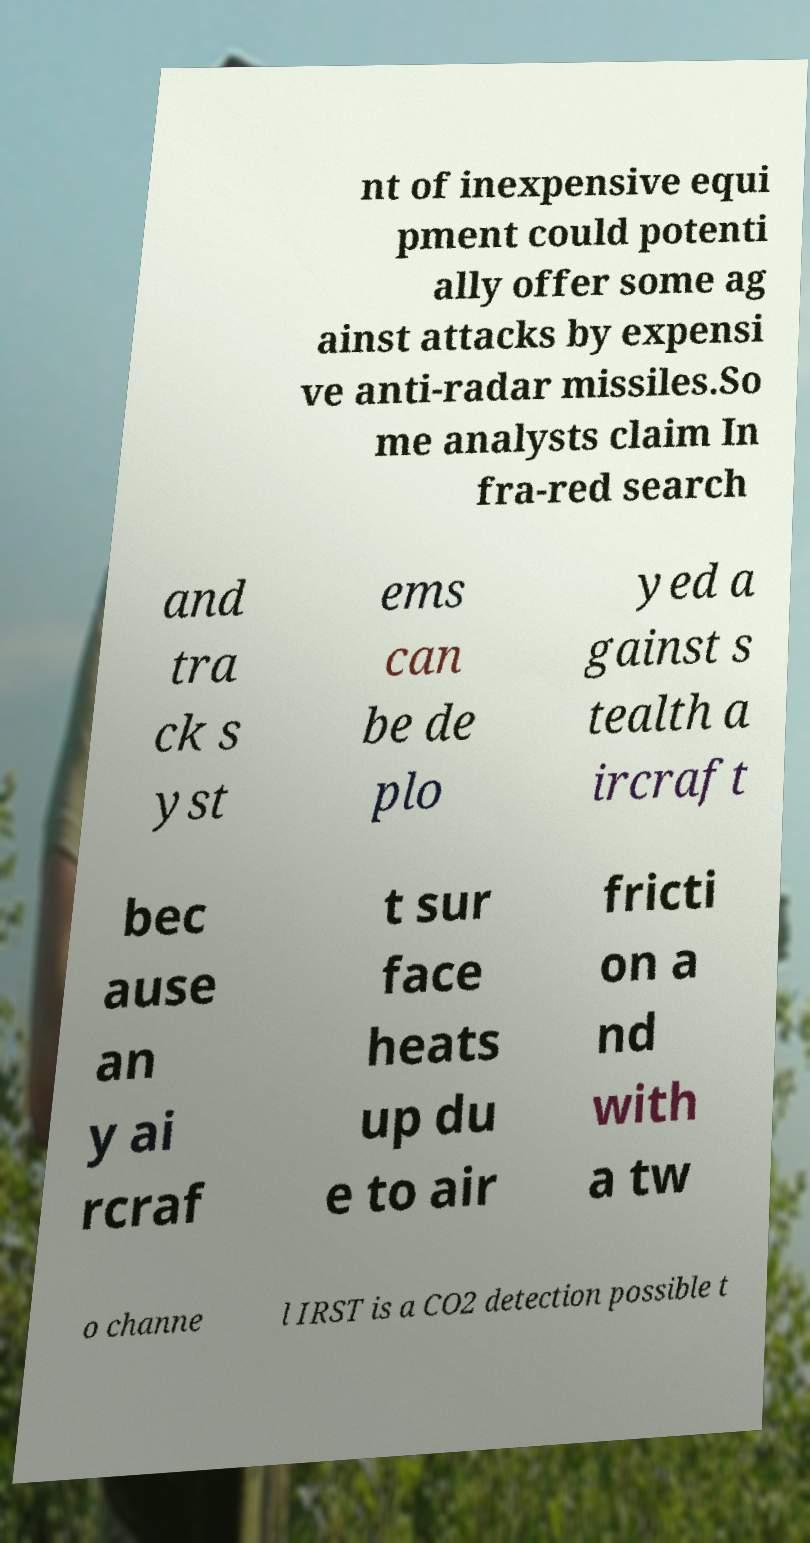Could you assist in decoding the text presented in this image and type it out clearly? nt of inexpensive equi pment could potenti ally offer some ag ainst attacks by expensi ve anti-radar missiles.So me analysts claim In fra-red search and tra ck s yst ems can be de plo yed a gainst s tealth a ircraft bec ause an y ai rcraf t sur face heats up du e to air fricti on a nd with a tw o channe l IRST is a CO2 detection possible t 